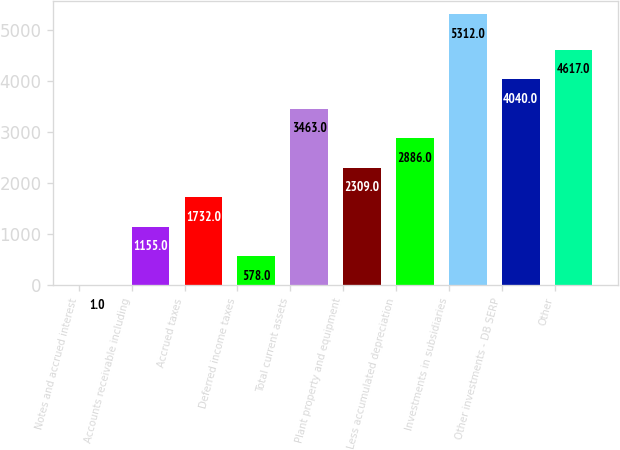<chart> <loc_0><loc_0><loc_500><loc_500><bar_chart><fcel>Notes and accrued interest<fcel>Accounts receivable including<fcel>Accrued taxes<fcel>Deferred income taxes<fcel>Total current assets<fcel>Plant property and equipment<fcel>Less accumulated depreciation<fcel>Investments in subsidiaries<fcel>Other investments - DB SERP<fcel>Other<nl><fcel>1<fcel>1155<fcel>1732<fcel>578<fcel>3463<fcel>2309<fcel>2886<fcel>5312<fcel>4040<fcel>4617<nl></chart> 